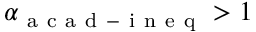<formula> <loc_0><loc_0><loc_500><loc_500>\alpha _ { a c a d - i n e q } > 1</formula> 